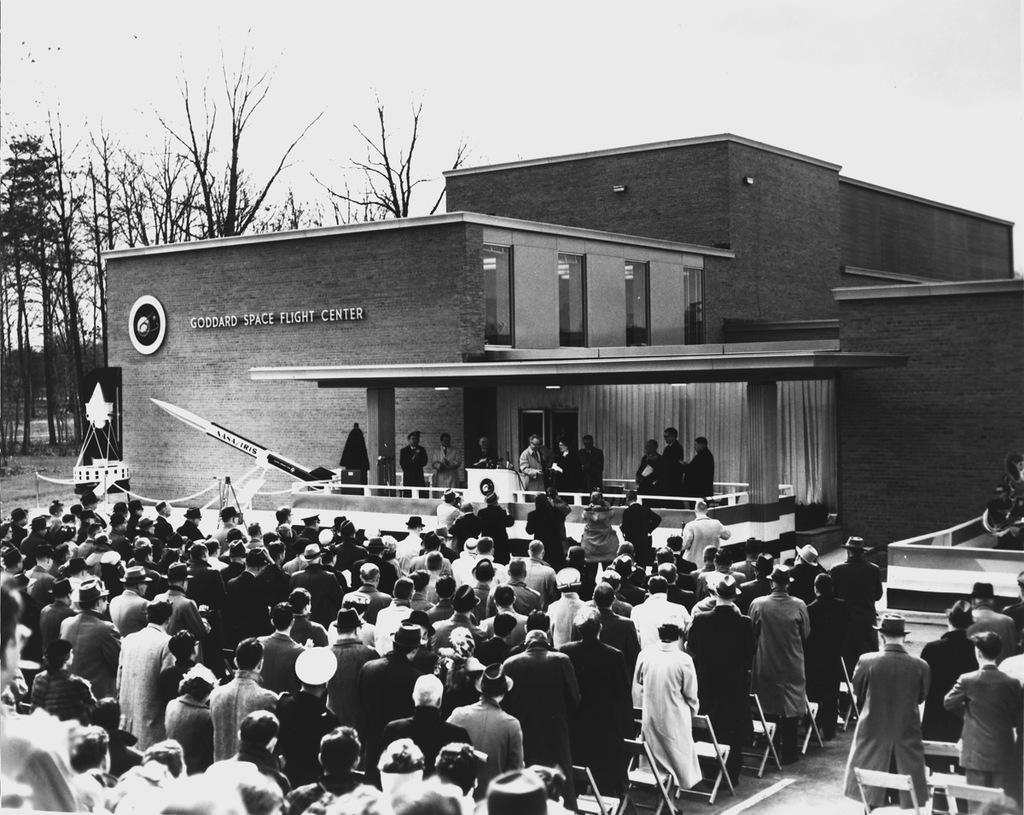Please provide a concise description of this image. This picture is clicked outside. In the foreground we can see the group of people seems to be standing on the ground and we can see the chairs. In the center we can see the group of people and we can see the microphones and a podium and some other objects and we can see the lights, building, text attached to the wall of the building. In the background we can see the sky, trees and the dry stems of the trees. 